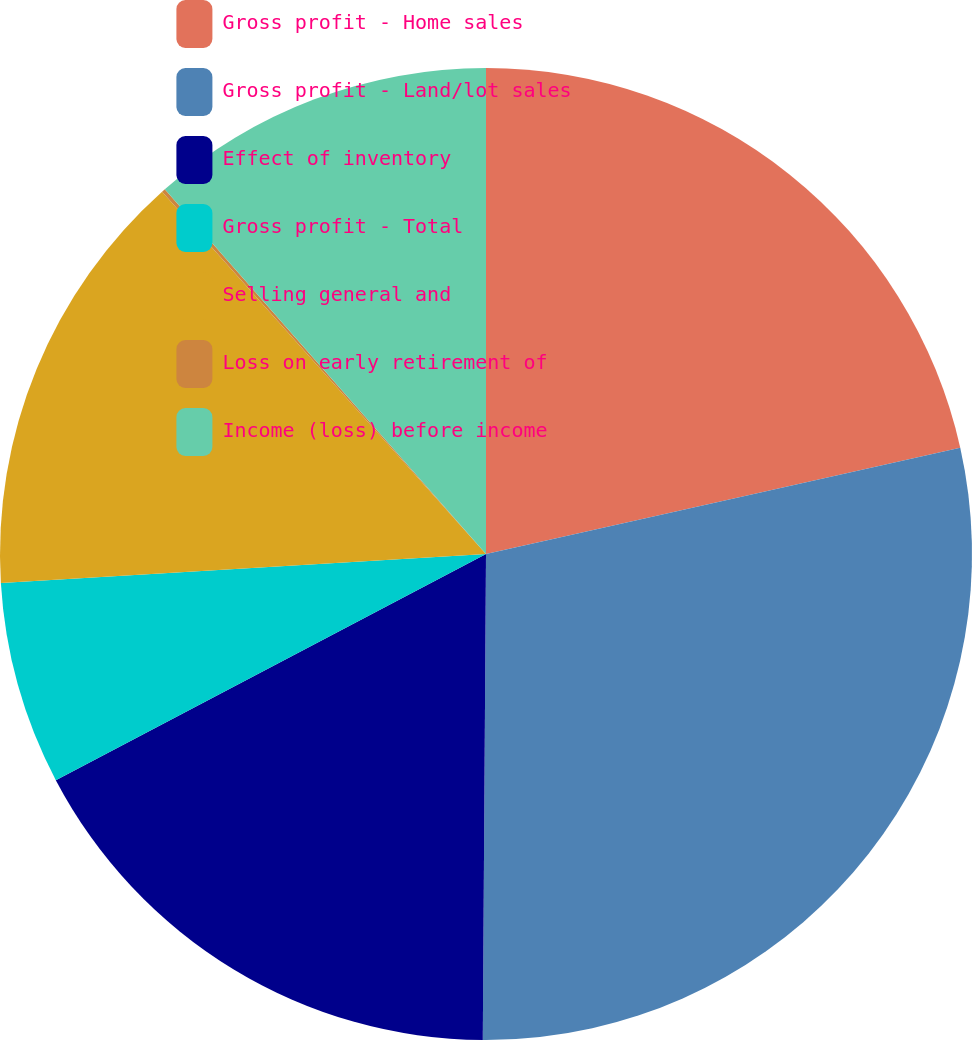<chart> <loc_0><loc_0><loc_500><loc_500><pie_chart><fcel>Gross profit - Home sales<fcel>Gross profit - Land/lot sales<fcel>Effect of inventory<fcel>Gross profit - Total<fcel>Selling general and<fcel>Loss on early retirement of<fcel>Income (loss) before income<nl><fcel>21.49%<fcel>28.61%<fcel>17.19%<fcel>6.75%<fcel>14.34%<fcel>0.12%<fcel>11.49%<nl></chart> 